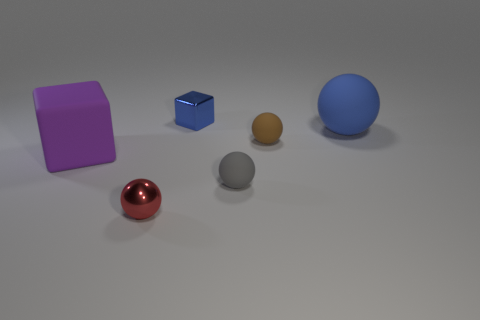There is a cube that is the same color as the large rubber ball; what is its material?
Offer a terse response. Metal. Does the tiny metal thing that is behind the big purple object have the same color as the large matte ball?
Keep it short and to the point. Yes. How many other things are there of the same color as the tiny metal cube?
Make the answer very short. 1. What number of other things are there of the same material as the red ball
Provide a succinct answer. 1. Are there more tiny red objects than metallic things?
Provide a short and direct response. No. There is a shiny object on the right side of the tiny red metallic object; is its shape the same as the purple thing?
Offer a very short reply. Yes. Is the number of brown objects less than the number of big purple metallic balls?
Your answer should be very brief. No. What material is the blue sphere that is the same size as the purple matte cube?
Your response must be concise. Rubber. Do the big matte sphere and the cube behind the tiny brown thing have the same color?
Keep it short and to the point. Yes. Is the number of red metallic spheres in front of the brown rubber sphere less than the number of small objects?
Offer a very short reply. Yes. 